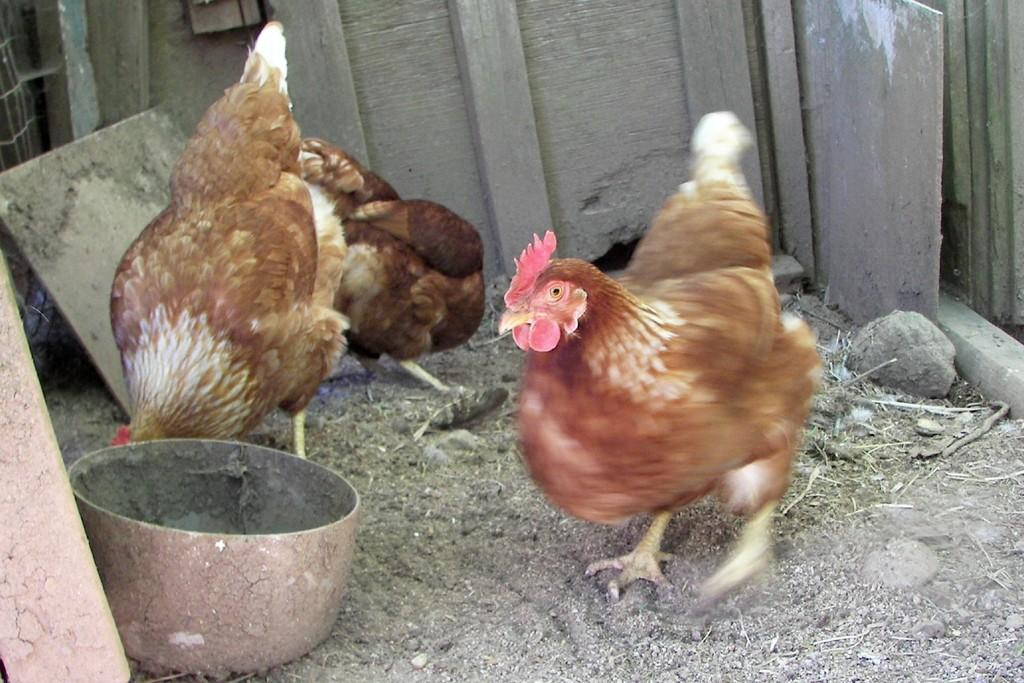How many hens are present in the image? There are three hens in the image. What is visible at the bottom of the image? There is ground visible at the bottom of the image. What type of objects can be seen in the background of the image? There are wooden pieces and a rock in the background of the image. Where is the bowl located in the image? The bowl is on the left side of the image. What type of lamp is hanging above the hens in the image? There is no lamp present in the image; it only features hens, ground, wooden pieces, a rock, and a bowl. 